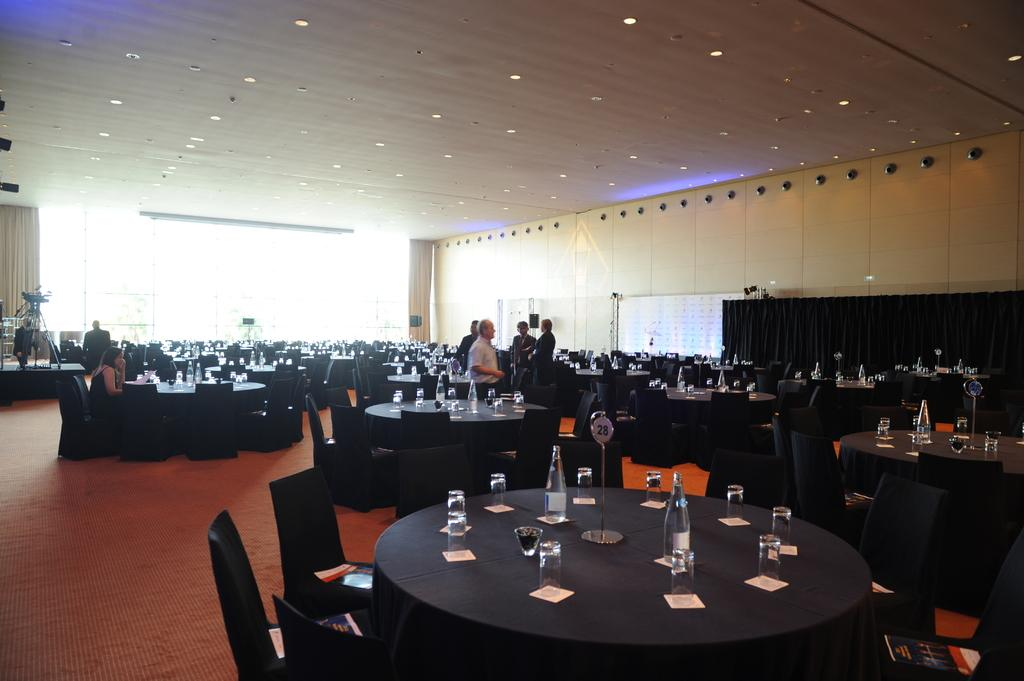What type of furniture is present in the image? There are tables and chairs in the image. What can be seen on the table in the image? There is a water bottle and glasses on the table. Are there any people visible in the image? Yes, there are people in the background of the image. What additional object can be seen in the background of the image? There is a video camera in the background of the image. What type of lace is being used to tie the chairs together in the image? There is no lace present in the image, and the chairs are not tied together. 